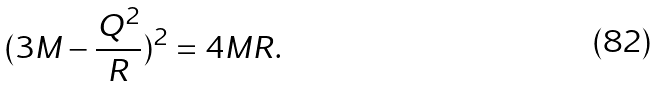<formula> <loc_0><loc_0><loc_500><loc_500>( 3 M - \frac { Q ^ { 2 } } { R } ) ^ { 2 } = 4 M R .</formula> 